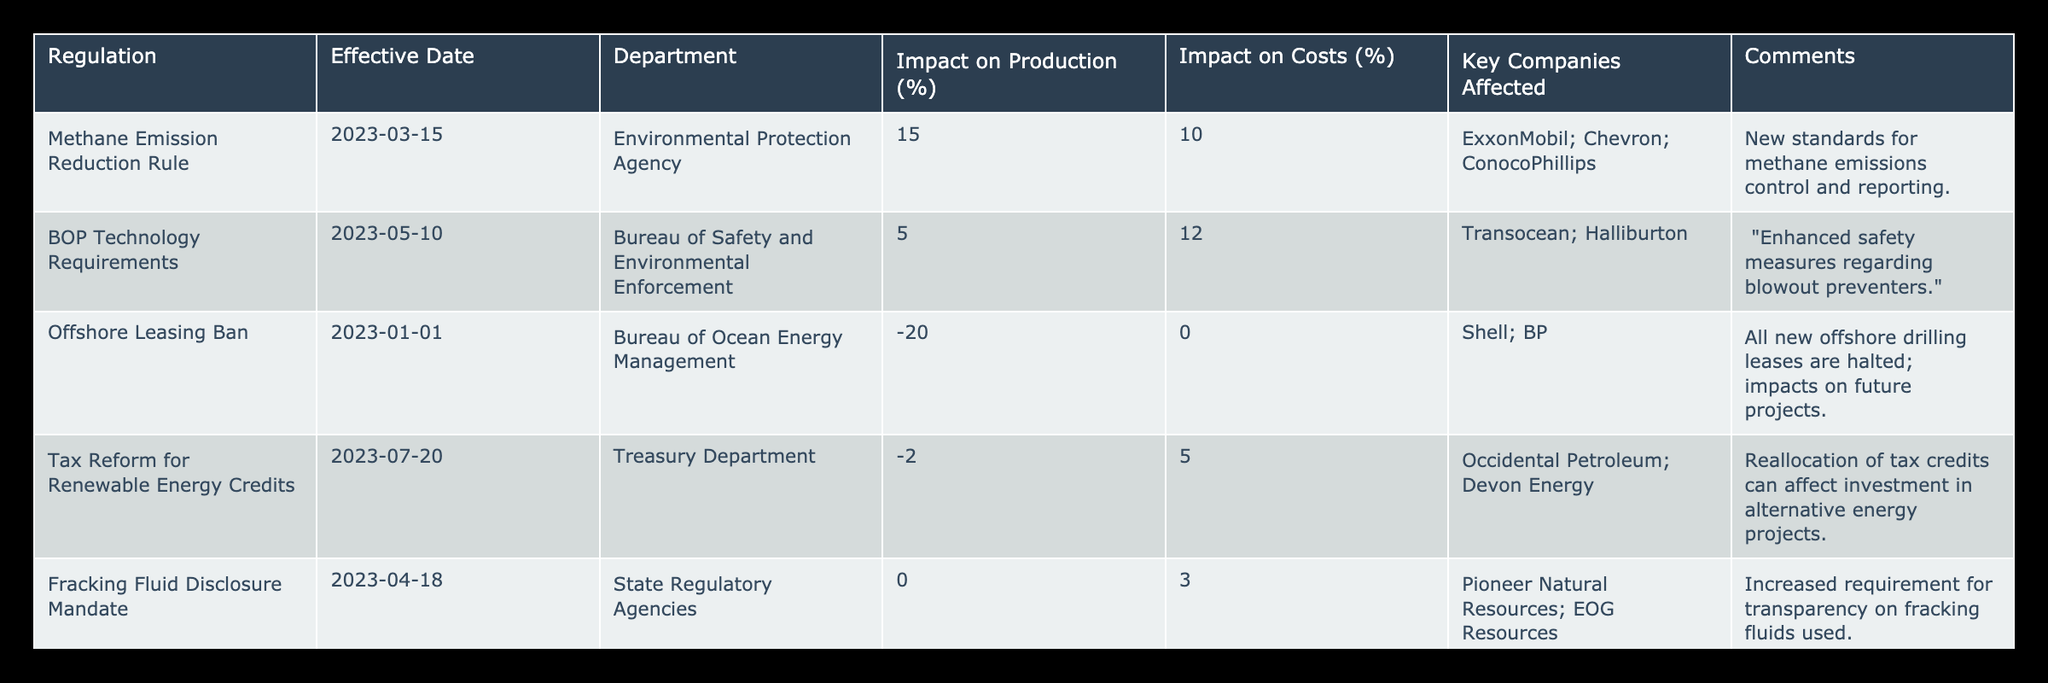What is the impact on production from the Offshore Leasing Ban? According to the table, the Offshore Leasing Ban has an impact on production of -20%. This value is directly retrieved from the "Impact on Production (%)" column for that specific regulation.
Answer: -20% Which regulation has the highest impact on costs? The table shows that the BOP Technology Requirements have the highest impact on costs at 12%. We compare the values in the "Impact on Costs (%)" column, and find that 12% is the largest among the listed regulations.
Answer: BOP Technology Requirements How many regulations resulted in a positive impact on production? By checking the "Impact on Production (%)" column, we can determine the regulations that are positive (greater than 0%). Only two regulations have a positive impact: Methane Emission Reduction Rule (15%) and BOP Technology Requirements (5%). Therefore, there are two regulations with a positive impact.
Answer: 2 What is the average impact on costs for all the regulations listed? First, we sum the cost impacts: 10 + 12 + 0 + 5 + 3 = 30. Then, we divide this total by the number of regulations, which is 5. So the average impact on costs is 30/5 = 6%.
Answer: 6% Is it true that the Fracking Fluid Disclosure Mandate has no impact on production? The table states that the Fracking Fluid Disclosure Mandate has an impact on production of 0%. Thus, the statement is true as the value reflects no change in production levels under this regulation.
Answer: Yes What combination of regulations has a combined impact on production of -5%? From the table, if we consider the Offshore Leasing Ban (-20%) and Tax Reform for Renewable Energy Credits (-2%), the combined production impact is -20 + (-2) = -22%. This does not match. However, we can sum the Offshore Leasing Ban (-20%) and Fracking Fluid Disclosure Mandate (0%), resulting in -20%, but none of the combinations yield -5%. This means no such combinations exist in the given regulations that total to -5%.
Answer: No combination exists How does the impact on costs from the Methane Emission Reduction Rule compare to that of the Tax Reform for Renewable Energy Credits? The impact on costs due to Methane Emission Reduction Rule is 10%, while the Tax Reform for Renewable Energy Credits shows an impact of 5%. Therefore, the Methane Rule has a higher impact on costs by 5 percentage points (10% - 5% = 5%).
Answer: Higher by 5 percentage points Which key company is affected by the BOP Technology Requirements? The table lists Transocean and Halliburton as the key companies affected by the BOP Technology Requirements regulation. This information can be found in the "Key Companies Affected" column corresponding to that regulation.
Answer: Transocean; Halliburton How many regulations specify a requirement for transparency? The only regulation that specifies a requirement for transparency is the Fracking Fluid Disclosure Mandate. Hence, from the table, only one regulation is identified to require transparency in its operations.
Answer: 1 